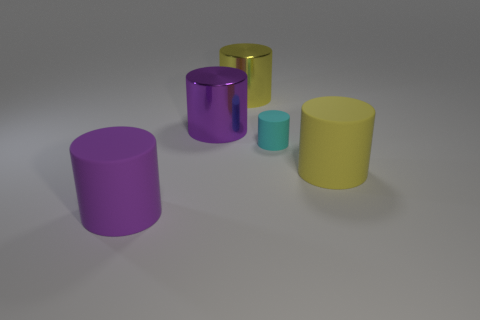Subtract all cyan cylinders. How many cylinders are left? 4 Subtract all tiny cylinders. How many cylinders are left? 4 Subtract all brown cylinders. Subtract all blue balls. How many cylinders are left? 5 Add 3 purple rubber cylinders. How many objects exist? 8 Subtract all tiny yellow metallic spheres. Subtract all tiny cyan matte cylinders. How many objects are left? 4 Add 4 tiny cylinders. How many tiny cylinders are left? 5 Add 4 small brown blocks. How many small brown blocks exist? 4 Subtract 0 cyan spheres. How many objects are left? 5 